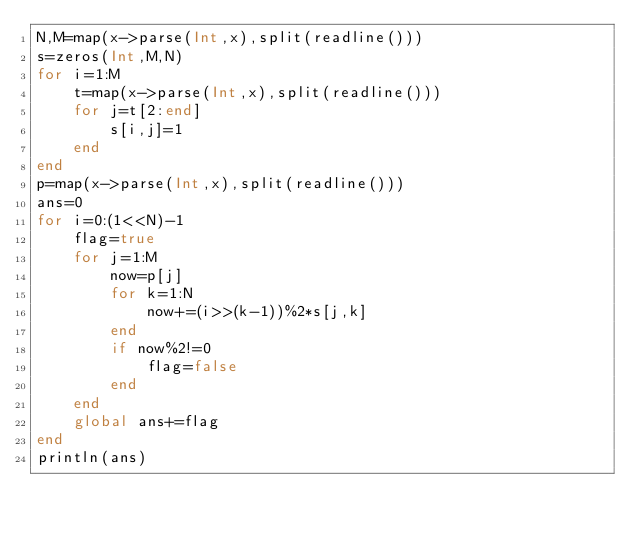<code> <loc_0><loc_0><loc_500><loc_500><_Julia_>N,M=map(x->parse(Int,x),split(readline()))
s=zeros(Int,M,N)
for i=1:M
	t=map(x->parse(Int,x),split(readline()))
	for j=t[2:end]
		s[i,j]=1
	end
end
p=map(x->parse(Int,x),split(readline()))
ans=0
for i=0:(1<<N)-1
	flag=true
	for j=1:M
		now=p[j]
		for k=1:N
			now+=(i>>(k-1))%2*s[j,k]
		end
		if now%2!=0
			flag=false
		end
	end
	global ans+=flag
end
println(ans)
</code> 